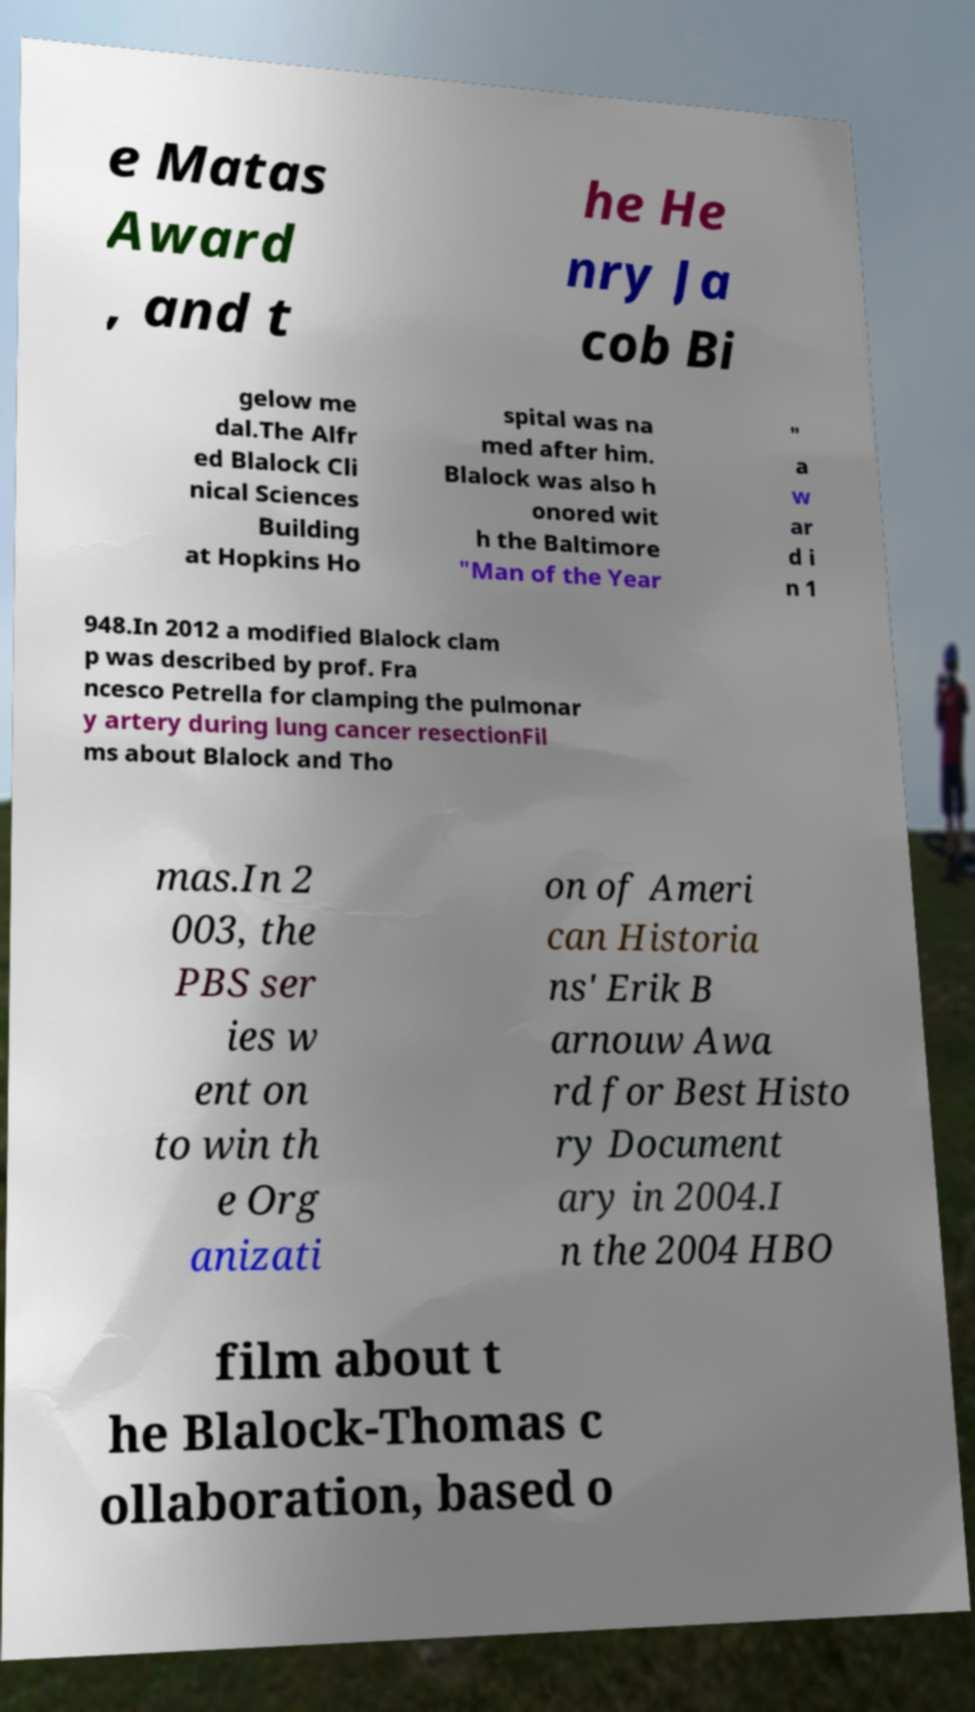Please identify and transcribe the text found in this image. e Matas Award , and t he He nry Ja cob Bi gelow me dal.The Alfr ed Blalock Cli nical Sciences Building at Hopkins Ho spital was na med after him. Blalock was also h onored wit h the Baltimore "Man of the Year " a w ar d i n 1 948.In 2012 a modified Blalock clam p was described by prof. Fra ncesco Petrella for clamping the pulmonar y artery during lung cancer resectionFil ms about Blalock and Tho mas.In 2 003, the PBS ser ies w ent on to win th e Org anizati on of Ameri can Historia ns' Erik B arnouw Awa rd for Best Histo ry Document ary in 2004.I n the 2004 HBO film about t he Blalock-Thomas c ollaboration, based o 